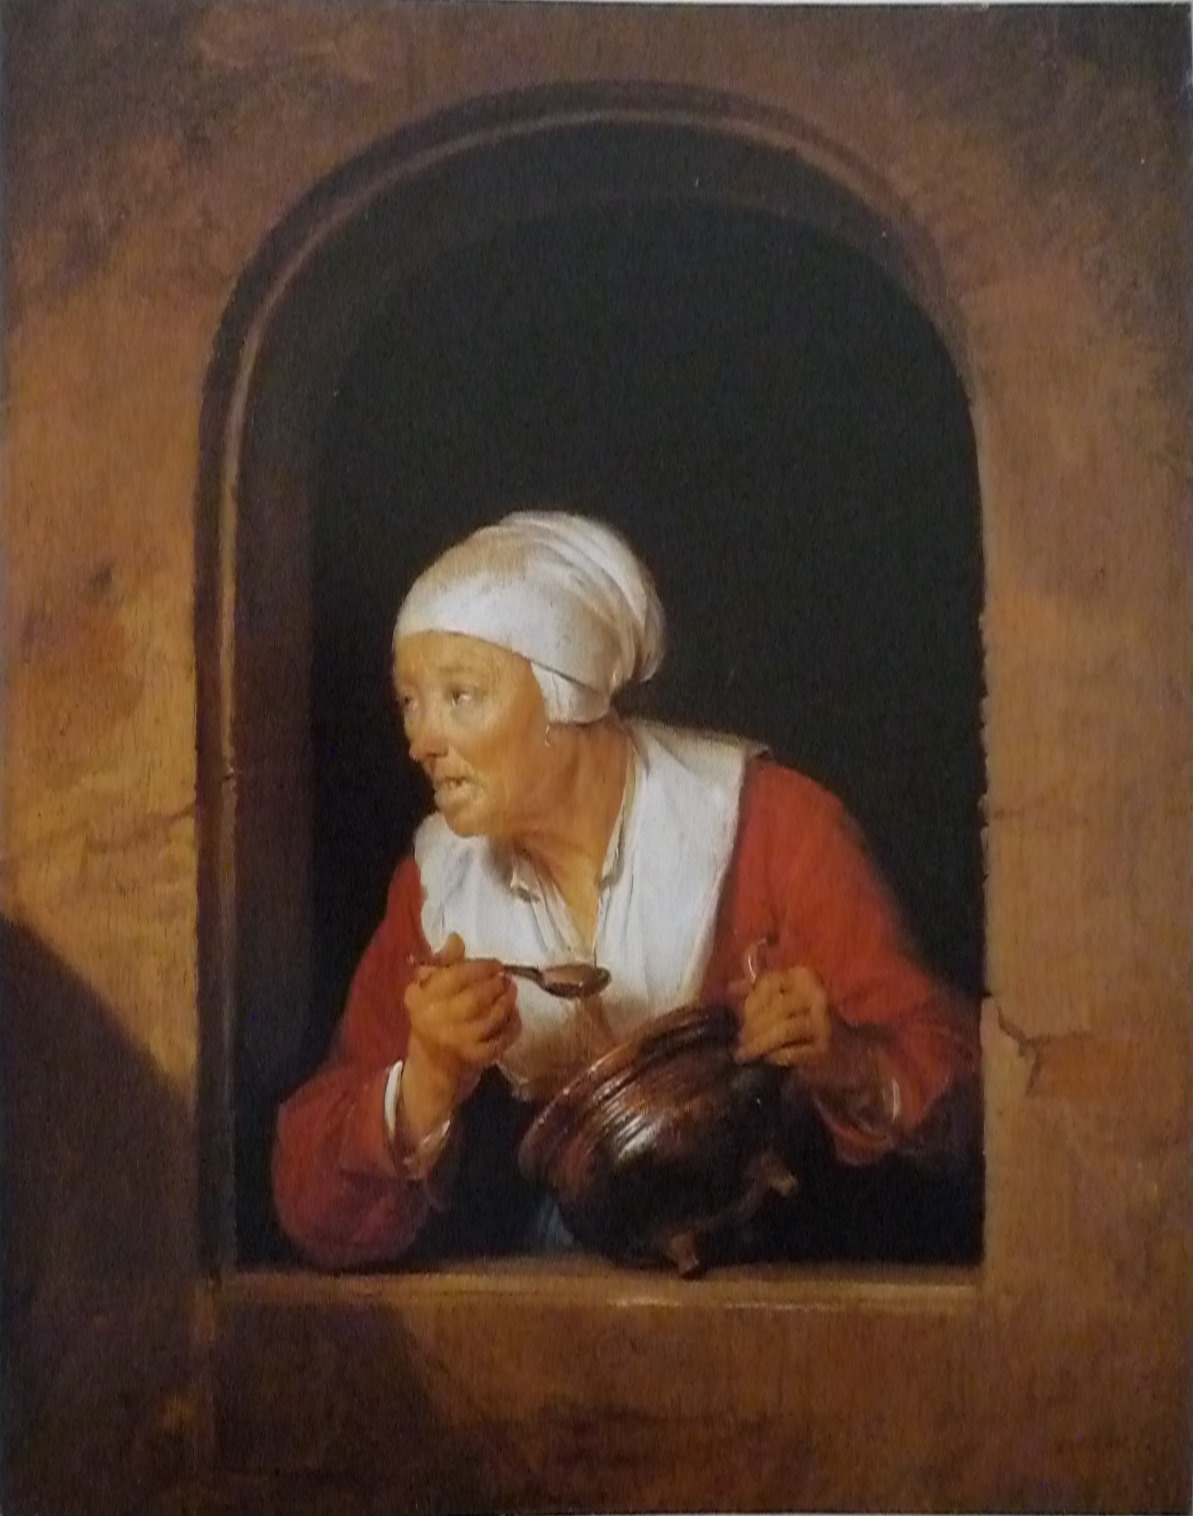Write a detailed description of the given image. The painting depicts an older woman with a look of surprised intent, as if she's been suddenly interrupted. She peers out from what appears to be a darkened window or opening, her white headscarf and red blouse providing a stark contrast to the shadowy background. The woman's expression, with her mouth slightly ajar and her eyes widened, suggests curiosity, astonishment, or concern. She holds what seems to be a brown earthenware jug close to her chest with one hand, while her other hand holds a shallow bowl. The realistic portrayal of textures; from her wrinkled skin, the fabric of her clothing, to the sheen on the jug; showcases the painter's skill at capturing fine details and imbuing the subject with a sense of immediacy. 